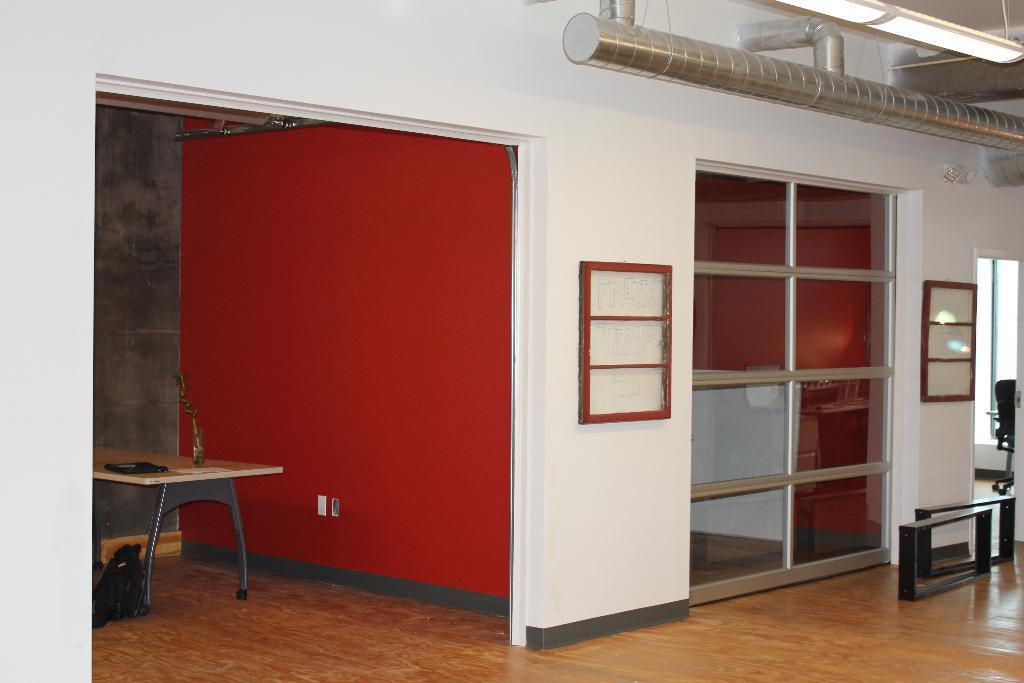Describe this image in one or two sentences. In this picture we can see a few objects on a table. There is a bag and black objects are visible on the floor. We can see some glass objects, a chair, other objects, pipes and lights are visible on top. 